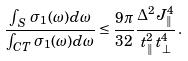<formula> <loc_0><loc_0><loc_500><loc_500>\frac { \int _ { \, S \, } \sigma _ { 1 } ( \omega ) d \omega } { \int _ { C T } \sigma _ { 1 } ( \omega ) d \omega } \leq \frac { 9 \pi } { 3 2 } \frac { \Delta ^ { 2 } J _ { \| } ^ { 4 } } { t _ { \| } ^ { 2 } \, t _ { \bot } ^ { 4 } } \, .</formula> 